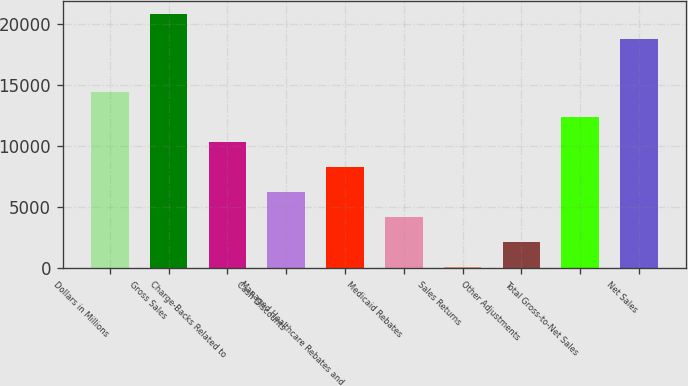Convert chart to OTSL. <chart><loc_0><loc_0><loc_500><loc_500><bar_chart><fcel>Dollars in Millions<fcel>Gross Sales<fcel>Charge-Backs Related to<fcel>Cash Discounts<fcel>Managed Healthcare Rebates and<fcel>Medicaid Rebates<fcel>Sales Returns<fcel>Other Adjustments<fcel>Total Gross-to-Net Sales<fcel>Net Sales<nl><fcel>14418.8<fcel>20853.4<fcel>10328<fcel>6237.2<fcel>8282.6<fcel>4191.8<fcel>101<fcel>2146.4<fcel>12373.4<fcel>18808<nl></chart> 